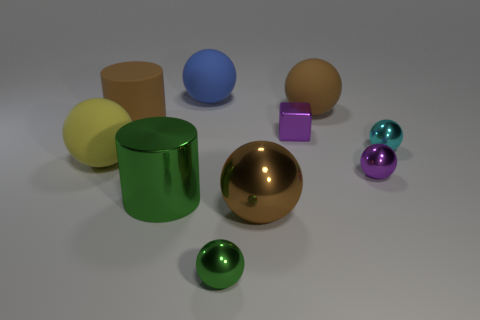What is the shape of the blue thing? sphere 